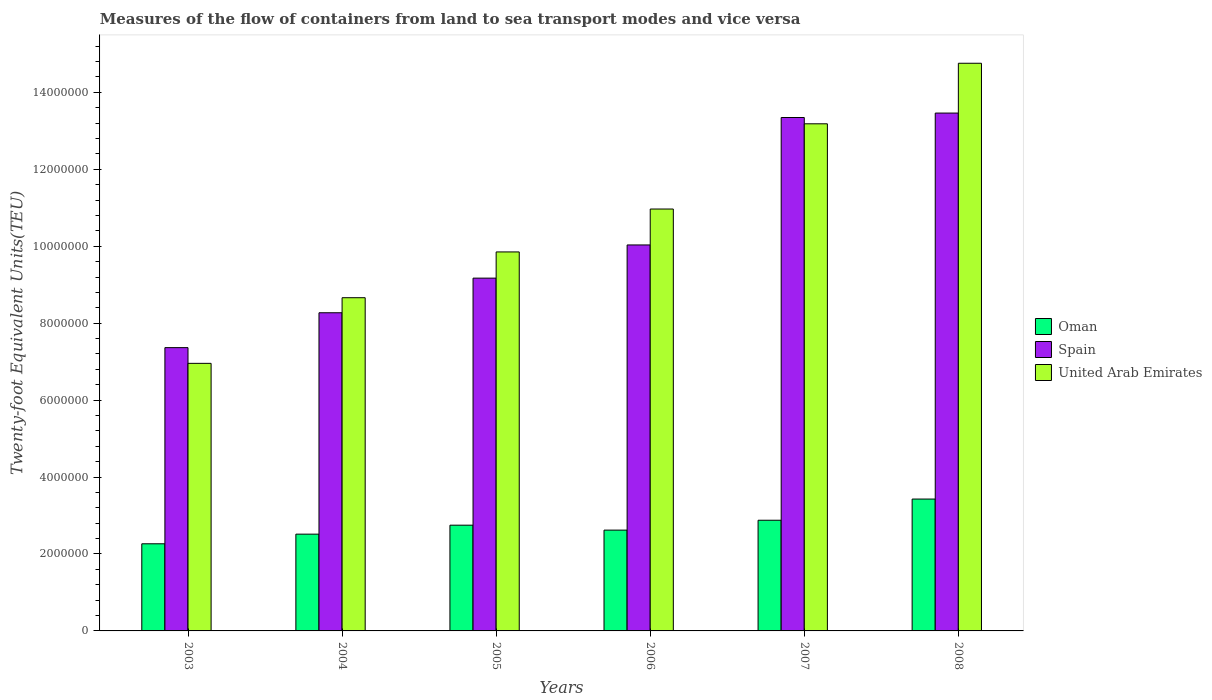How many groups of bars are there?
Your answer should be compact. 6. Are the number of bars per tick equal to the number of legend labels?
Your answer should be very brief. Yes. How many bars are there on the 3rd tick from the left?
Keep it short and to the point. 3. How many bars are there on the 5th tick from the right?
Offer a very short reply. 3. In how many cases, is the number of bars for a given year not equal to the number of legend labels?
Your answer should be compact. 0. What is the container port traffic in Oman in 2003?
Give a very brief answer. 2.26e+06. Across all years, what is the maximum container port traffic in United Arab Emirates?
Ensure brevity in your answer.  1.48e+07. Across all years, what is the minimum container port traffic in Spain?
Provide a short and direct response. 7.36e+06. What is the total container port traffic in Spain in the graph?
Ensure brevity in your answer.  6.16e+07. What is the difference between the container port traffic in Oman in 2004 and that in 2006?
Offer a very short reply. -1.05e+05. What is the difference between the container port traffic in Oman in 2006 and the container port traffic in United Arab Emirates in 2004?
Your response must be concise. -6.04e+06. What is the average container port traffic in Oman per year?
Provide a succinct answer. 2.74e+06. In the year 2007, what is the difference between the container port traffic in Oman and container port traffic in Spain?
Provide a short and direct response. -1.05e+07. In how many years, is the container port traffic in Oman greater than 13600000 TEU?
Provide a succinct answer. 0. What is the ratio of the container port traffic in United Arab Emirates in 2003 to that in 2006?
Ensure brevity in your answer.  0.63. Is the difference between the container port traffic in Oman in 2004 and 2007 greater than the difference between the container port traffic in Spain in 2004 and 2007?
Give a very brief answer. Yes. What is the difference between the highest and the second highest container port traffic in Spain?
Give a very brief answer. 1.15e+05. What is the difference between the highest and the lowest container port traffic in Oman?
Your answer should be compact. 1.16e+06. Is the sum of the container port traffic in Oman in 2005 and 2006 greater than the maximum container port traffic in United Arab Emirates across all years?
Provide a short and direct response. No. What does the 1st bar from the left in 2008 represents?
Offer a terse response. Oman. What does the 3rd bar from the right in 2003 represents?
Your answer should be very brief. Oman. How many bars are there?
Offer a terse response. 18. Are all the bars in the graph horizontal?
Keep it short and to the point. No. How many years are there in the graph?
Your answer should be very brief. 6. What is the difference between two consecutive major ticks on the Y-axis?
Make the answer very short. 2.00e+06. Does the graph contain any zero values?
Make the answer very short. No. Does the graph contain grids?
Give a very brief answer. No. Where does the legend appear in the graph?
Ensure brevity in your answer.  Center right. How are the legend labels stacked?
Keep it short and to the point. Vertical. What is the title of the graph?
Ensure brevity in your answer.  Measures of the flow of containers from land to sea transport modes and vice versa. Does "Myanmar" appear as one of the legend labels in the graph?
Your response must be concise. No. What is the label or title of the X-axis?
Make the answer very short. Years. What is the label or title of the Y-axis?
Keep it short and to the point. Twenty-foot Equivalent Units(TEU). What is the Twenty-foot Equivalent Units(TEU) of Oman in 2003?
Ensure brevity in your answer.  2.26e+06. What is the Twenty-foot Equivalent Units(TEU) in Spain in 2003?
Make the answer very short. 7.36e+06. What is the Twenty-foot Equivalent Units(TEU) of United Arab Emirates in 2003?
Your answer should be compact. 6.96e+06. What is the Twenty-foot Equivalent Units(TEU) of Oman in 2004?
Give a very brief answer. 2.52e+06. What is the Twenty-foot Equivalent Units(TEU) of Spain in 2004?
Ensure brevity in your answer.  8.27e+06. What is the Twenty-foot Equivalent Units(TEU) of United Arab Emirates in 2004?
Offer a terse response. 8.66e+06. What is the Twenty-foot Equivalent Units(TEU) in Oman in 2005?
Offer a very short reply. 2.75e+06. What is the Twenty-foot Equivalent Units(TEU) in Spain in 2005?
Keep it short and to the point. 9.17e+06. What is the Twenty-foot Equivalent Units(TEU) in United Arab Emirates in 2005?
Keep it short and to the point. 9.85e+06. What is the Twenty-foot Equivalent Units(TEU) in Oman in 2006?
Give a very brief answer. 2.62e+06. What is the Twenty-foot Equivalent Units(TEU) of Spain in 2006?
Offer a very short reply. 1.00e+07. What is the Twenty-foot Equivalent Units(TEU) of United Arab Emirates in 2006?
Your answer should be compact. 1.10e+07. What is the Twenty-foot Equivalent Units(TEU) of Oman in 2007?
Provide a succinct answer. 2.88e+06. What is the Twenty-foot Equivalent Units(TEU) in Spain in 2007?
Offer a very short reply. 1.33e+07. What is the Twenty-foot Equivalent Units(TEU) of United Arab Emirates in 2007?
Offer a terse response. 1.32e+07. What is the Twenty-foot Equivalent Units(TEU) of Oman in 2008?
Offer a terse response. 3.43e+06. What is the Twenty-foot Equivalent Units(TEU) in Spain in 2008?
Give a very brief answer. 1.35e+07. What is the Twenty-foot Equivalent Units(TEU) in United Arab Emirates in 2008?
Ensure brevity in your answer.  1.48e+07. Across all years, what is the maximum Twenty-foot Equivalent Units(TEU) in Oman?
Provide a succinct answer. 3.43e+06. Across all years, what is the maximum Twenty-foot Equivalent Units(TEU) in Spain?
Keep it short and to the point. 1.35e+07. Across all years, what is the maximum Twenty-foot Equivalent Units(TEU) of United Arab Emirates?
Give a very brief answer. 1.48e+07. Across all years, what is the minimum Twenty-foot Equivalent Units(TEU) of Oman?
Provide a succinct answer. 2.26e+06. Across all years, what is the minimum Twenty-foot Equivalent Units(TEU) of Spain?
Offer a very short reply. 7.36e+06. Across all years, what is the minimum Twenty-foot Equivalent Units(TEU) in United Arab Emirates?
Offer a terse response. 6.96e+06. What is the total Twenty-foot Equivalent Units(TEU) in Oman in the graph?
Provide a short and direct response. 1.65e+07. What is the total Twenty-foot Equivalent Units(TEU) of Spain in the graph?
Make the answer very short. 6.16e+07. What is the total Twenty-foot Equivalent Units(TEU) in United Arab Emirates in the graph?
Your answer should be very brief. 6.44e+07. What is the difference between the Twenty-foot Equivalent Units(TEU) in Oman in 2003 and that in 2004?
Your answer should be compact. -2.51e+05. What is the difference between the Twenty-foot Equivalent Units(TEU) in Spain in 2003 and that in 2004?
Ensure brevity in your answer.  -9.06e+05. What is the difference between the Twenty-foot Equivalent Units(TEU) in United Arab Emirates in 2003 and that in 2004?
Make the answer very short. -1.71e+06. What is the difference between the Twenty-foot Equivalent Units(TEU) of Oman in 2003 and that in 2005?
Offer a very short reply. -4.84e+05. What is the difference between the Twenty-foot Equivalent Units(TEU) in Spain in 2003 and that in 2005?
Provide a succinct answer. -1.81e+06. What is the difference between the Twenty-foot Equivalent Units(TEU) of United Arab Emirates in 2003 and that in 2005?
Provide a short and direct response. -2.90e+06. What is the difference between the Twenty-foot Equivalent Units(TEU) in Oman in 2003 and that in 2006?
Your answer should be very brief. -3.56e+05. What is the difference between the Twenty-foot Equivalent Units(TEU) in Spain in 2003 and that in 2006?
Offer a terse response. -2.67e+06. What is the difference between the Twenty-foot Equivalent Units(TEU) in United Arab Emirates in 2003 and that in 2006?
Offer a very short reply. -4.01e+06. What is the difference between the Twenty-foot Equivalent Units(TEU) of Oman in 2003 and that in 2007?
Give a very brief answer. -6.12e+05. What is the difference between the Twenty-foot Equivalent Units(TEU) in Spain in 2003 and that in 2007?
Your answer should be compact. -5.98e+06. What is the difference between the Twenty-foot Equivalent Units(TEU) in United Arab Emirates in 2003 and that in 2007?
Ensure brevity in your answer.  -6.23e+06. What is the difference between the Twenty-foot Equivalent Units(TEU) in Oman in 2003 and that in 2008?
Make the answer very short. -1.16e+06. What is the difference between the Twenty-foot Equivalent Units(TEU) in Spain in 2003 and that in 2008?
Ensure brevity in your answer.  -6.10e+06. What is the difference between the Twenty-foot Equivalent Units(TEU) of United Arab Emirates in 2003 and that in 2008?
Keep it short and to the point. -7.80e+06. What is the difference between the Twenty-foot Equivalent Units(TEU) in Oman in 2004 and that in 2005?
Make the answer very short. -2.33e+05. What is the difference between the Twenty-foot Equivalent Units(TEU) of Spain in 2004 and that in 2005?
Your answer should be compact. -9.00e+05. What is the difference between the Twenty-foot Equivalent Units(TEU) of United Arab Emirates in 2004 and that in 2005?
Give a very brief answer. -1.19e+06. What is the difference between the Twenty-foot Equivalent Units(TEU) in Oman in 2004 and that in 2006?
Your answer should be very brief. -1.05e+05. What is the difference between the Twenty-foot Equivalent Units(TEU) in Spain in 2004 and that in 2006?
Ensure brevity in your answer.  -1.76e+06. What is the difference between the Twenty-foot Equivalent Units(TEU) in United Arab Emirates in 2004 and that in 2006?
Provide a succinct answer. -2.31e+06. What is the difference between the Twenty-foot Equivalent Units(TEU) of Oman in 2004 and that in 2007?
Your response must be concise. -3.61e+05. What is the difference between the Twenty-foot Equivalent Units(TEU) of Spain in 2004 and that in 2007?
Provide a succinct answer. -5.08e+06. What is the difference between the Twenty-foot Equivalent Units(TEU) in United Arab Emirates in 2004 and that in 2007?
Make the answer very short. -4.52e+06. What is the difference between the Twenty-foot Equivalent Units(TEU) of Oman in 2004 and that in 2008?
Make the answer very short. -9.12e+05. What is the difference between the Twenty-foot Equivalent Units(TEU) of Spain in 2004 and that in 2008?
Offer a very short reply. -5.19e+06. What is the difference between the Twenty-foot Equivalent Units(TEU) in United Arab Emirates in 2004 and that in 2008?
Offer a terse response. -6.09e+06. What is the difference between the Twenty-foot Equivalent Units(TEU) in Oman in 2005 and that in 2006?
Offer a very short reply. 1.28e+05. What is the difference between the Twenty-foot Equivalent Units(TEU) of Spain in 2005 and that in 2006?
Provide a short and direct response. -8.63e+05. What is the difference between the Twenty-foot Equivalent Units(TEU) in United Arab Emirates in 2005 and that in 2006?
Ensure brevity in your answer.  -1.12e+06. What is the difference between the Twenty-foot Equivalent Units(TEU) of Oman in 2005 and that in 2007?
Provide a succinct answer. -1.28e+05. What is the difference between the Twenty-foot Equivalent Units(TEU) of Spain in 2005 and that in 2007?
Your answer should be very brief. -4.18e+06. What is the difference between the Twenty-foot Equivalent Units(TEU) of United Arab Emirates in 2005 and that in 2007?
Your response must be concise. -3.33e+06. What is the difference between the Twenty-foot Equivalent Units(TEU) in Oman in 2005 and that in 2008?
Give a very brief answer. -6.79e+05. What is the difference between the Twenty-foot Equivalent Units(TEU) in Spain in 2005 and that in 2008?
Your response must be concise. -4.29e+06. What is the difference between the Twenty-foot Equivalent Units(TEU) of United Arab Emirates in 2005 and that in 2008?
Make the answer very short. -4.90e+06. What is the difference between the Twenty-foot Equivalent Units(TEU) of Oman in 2006 and that in 2007?
Your answer should be very brief. -2.57e+05. What is the difference between the Twenty-foot Equivalent Units(TEU) of Spain in 2006 and that in 2007?
Provide a short and direct response. -3.31e+06. What is the difference between the Twenty-foot Equivalent Units(TEU) in United Arab Emirates in 2006 and that in 2007?
Your answer should be very brief. -2.22e+06. What is the difference between the Twenty-foot Equivalent Units(TEU) in Oman in 2006 and that in 2008?
Offer a terse response. -8.08e+05. What is the difference between the Twenty-foot Equivalent Units(TEU) of Spain in 2006 and that in 2008?
Provide a succinct answer. -3.43e+06. What is the difference between the Twenty-foot Equivalent Units(TEU) in United Arab Emirates in 2006 and that in 2008?
Ensure brevity in your answer.  -3.79e+06. What is the difference between the Twenty-foot Equivalent Units(TEU) of Oman in 2007 and that in 2008?
Give a very brief answer. -5.51e+05. What is the difference between the Twenty-foot Equivalent Units(TEU) of Spain in 2007 and that in 2008?
Ensure brevity in your answer.  -1.15e+05. What is the difference between the Twenty-foot Equivalent Units(TEU) in United Arab Emirates in 2007 and that in 2008?
Your answer should be compact. -1.57e+06. What is the difference between the Twenty-foot Equivalent Units(TEU) in Oman in 2003 and the Twenty-foot Equivalent Units(TEU) in Spain in 2004?
Keep it short and to the point. -6.01e+06. What is the difference between the Twenty-foot Equivalent Units(TEU) in Oman in 2003 and the Twenty-foot Equivalent Units(TEU) in United Arab Emirates in 2004?
Ensure brevity in your answer.  -6.40e+06. What is the difference between the Twenty-foot Equivalent Units(TEU) of Spain in 2003 and the Twenty-foot Equivalent Units(TEU) of United Arab Emirates in 2004?
Keep it short and to the point. -1.30e+06. What is the difference between the Twenty-foot Equivalent Units(TEU) in Oman in 2003 and the Twenty-foot Equivalent Units(TEU) in Spain in 2005?
Offer a very short reply. -6.91e+06. What is the difference between the Twenty-foot Equivalent Units(TEU) in Oman in 2003 and the Twenty-foot Equivalent Units(TEU) in United Arab Emirates in 2005?
Provide a short and direct response. -7.59e+06. What is the difference between the Twenty-foot Equivalent Units(TEU) in Spain in 2003 and the Twenty-foot Equivalent Units(TEU) in United Arab Emirates in 2005?
Your response must be concise. -2.49e+06. What is the difference between the Twenty-foot Equivalent Units(TEU) in Oman in 2003 and the Twenty-foot Equivalent Units(TEU) in Spain in 2006?
Your answer should be very brief. -7.77e+06. What is the difference between the Twenty-foot Equivalent Units(TEU) in Oman in 2003 and the Twenty-foot Equivalent Units(TEU) in United Arab Emirates in 2006?
Ensure brevity in your answer.  -8.70e+06. What is the difference between the Twenty-foot Equivalent Units(TEU) of Spain in 2003 and the Twenty-foot Equivalent Units(TEU) of United Arab Emirates in 2006?
Provide a short and direct response. -3.60e+06. What is the difference between the Twenty-foot Equivalent Units(TEU) in Oman in 2003 and the Twenty-foot Equivalent Units(TEU) in Spain in 2007?
Offer a very short reply. -1.11e+07. What is the difference between the Twenty-foot Equivalent Units(TEU) in Oman in 2003 and the Twenty-foot Equivalent Units(TEU) in United Arab Emirates in 2007?
Your answer should be very brief. -1.09e+07. What is the difference between the Twenty-foot Equivalent Units(TEU) of Spain in 2003 and the Twenty-foot Equivalent Units(TEU) of United Arab Emirates in 2007?
Your answer should be compact. -5.82e+06. What is the difference between the Twenty-foot Equivalent Units(TEU) of Oman in 2003 and the Twenty-foot Equivalent Units(TEU) of Spain in 2008?
Ensure brevity in your answer.  -1.12e+07. What is the difference between the Twenty-foot Equivalent Units(TEU) of Oman in 2003 and the Twenty-foot Equivalent Units(TEU) of United Arab Emirates in 2008?
Your answer should be very brief. -1.25e+07. What is the difference between the Twenty-foot Equivalent Units(TEU) of Spain in 2003 and the Twenty-foot Equivalent Units(TEU) of United Arab Emirates in 2008?
Your answer should be compact. -7.39e+06. What is the difference between the Twenty-foot Equivalent Units(TEU) in Oman in 2004 and the Twenty-foot Equivalent Units(TEU) in Spain in 2005?
Make the answer very short. -6.66e+06. What is the difference between the Twenty-foot Equivalent Units(TEU) of Oman in 2004 and the Twenty-foot Equivalent Units(TEU) of United Arab Emirates in 2005?
Provide a short and direct response. -7.34e+06. What is the difference between the Twenty-foot Equivalent Units(TEU) in Spain in 2004 and the Twenty-foot Equivalent Units(TEU) in United Arab Emirates in 2005?
Provide a succinct answer. -1.58e+06. What is the difference between the Twenty-foot Equivalent Units(TEU) in Oman in 2004 and the Twenty-foot Equivalent Units(TEU) in Spain in 2006?
Keep it short and to the point. -7.52e+06. What is the difference between the Twenty-foot Equivalent Units(TEU) of Oman in 2004 and the Twenty-foot Equivalent Units(TEU) of United Arab Emirates in 2006?
Offer a very short reply. -8.45e+06. What is the difference between the Twenty-foot Equivalent Units(TEU) of Spain in 2004 and the Twenty-foot Equivalent Units(TEU) of United Arab Emirates in 2006?
Your response must be concise. -2.70e+06. What is the difference between the Twenty-foot Equivalent Units(TEU) of Oman in 2004 and the Twenty-foot Equivalent Units(TEU) of Spain in 2007?
Your response must be concise. -1.08e+07. What is the difference between the Twenty-foot Equivalent Units(TEU) in Oman in 2004 and the Twenty-foot Equivalent Units(TEU) in United Arab Emirates in 2007?
Ensure brevity in your answer.  -1.07e+07. What is the difference between the Twenty-foot Equivalent Units(TEU) in Spain in 2004 and the Twenty-foot Equivalent Units(TEU) in United Arab Emirates in 2007?
Offer a very short reply. -4.91e+06. What is the difference between the Twenty-foot Equivalent Units(TEU) of Oman in 2004 and the Twenty-foot Equivalent Units(TEU) of Spain in 2008?
Provide a succinct answer. -1.09e+07. What is the difference between the Twenty-foot Equivalent Units(TEU) of Oman in 2004 and the Twenty-foot Equivalent Units(TEU) of United Arab Emirates in 2008?
Give a very brief answer. -1.22e+07. What is the difference between the Twenty-foot Equivalent Units(TEU) of Spain in 2004 and the Twenty-foot Equivalent Units(TEU) of United Arab Emirates in 2008?
Offer a very short reply. -6.49e+06. What is the difference between the Twenty-foot Equivalent Units(TEU) of Oman in 2005 and the Twenty-foot Equivalent Units(TEU) of Spain in 2006?
Your response must be concise. -7.28e+06. What is the difference between the Twenty-foot Equivalent Units(TEU) in Oman in 2005 and the Twenty-foot Equivalent Units(TEU) in United Arab Emirates in 2006?
Keep it short and to the point. -8.22e+06. What is the difference between the Twenty-foot Equivalent Units(TEU) in Spain in 2005 and the Twenty-foot Equivalent Units(TEU) in United Arab Emirates in 2006?
Provide a short and direct response. -1.80e+06. What is the difference between the Twenty-foot Equivalent Units(TEU) of Oman in 2005 and the Twenty-foot Equivalent Units(TEU) of Spain in 2007?
Offer a very short reply. -1.06e+07. What is the difference between the Twenty-foot Equivalent Units(TEU) of Oman in 2005 and the Twenty-foot Equivalent Units(TEU) of United Arab Emirates in 2007?
Keep it short and to the point. -1.04e+07. What is the difference between the Twenty-foot Equivalent Units(TEU) in Spain in 2005 and the Twenty-foot Equivalent Units(TEU) in United Arab Emirates in 2007?
Your answer should be compact. -4.01e+06. What is the difference between the Twenty-foot Equivalent Units(TEU) of Oman in 2005 and the Twenty-foot Equivalent Units(TEU) of Spain in 2008?
Offer a very short reply. -1.07e+07. What is the difference between the Twenty-foot Equivalent Units(TEU) of Oman in 2005 and the Twenty-foot Equivalent Units(TEU) of United Arab Emirates in 2008?
Give a very brief answer. -1.20e+07. What is the difference between the Twenty-foot Equivalent Units(TEU) in Spain in 2005 and the Twenty-foot Equivalent Units(TEU) in United Arab Emirates in 2008?
Keep it short and to the point. -5.59e+06. What is the difference between the Twenty-foot Equivalent Units(TEU) of Oman in 2006 and the Twenty-foot Equivalent Units(TEU) of Spain in 2007?
Offer a very short reply. -1.07e+07. What is the difference between the Twenty-foot Equivalent Units(TEU) in Oman in 2006 and the Twenty-foot Equivalent Units(TEU) in United Arab Emirates in 2007?
Offer a terse response. -1.06e+07. What is the difference between the Twenty-foot Equivalent Units(TEU) in Spain in 2006 and the Twenty-foot Equivalent Units(TEU) in United Arab Emirates in 2007?
Your answer should be very brief. -3.15e+06. What is the difference between the Twenty-foot Equivalent Units(TEU) of Oman in 2006 and the Twenty-foot Equivalent Units(TEU) of Spain in 2008?
Provide a short and direct response. -1.08e+07. What is the difference between the Twenty-foot Equivalent Units(TEU) of Oman in 2006 and the Twenty-foot Equivalent Units(TEU) of United Arab Emirates in 2008?
Ensure brevity in your answer.  -1.21e+07. What is the difference between the Twenty-foot Equivalent Units(TEU) in Spain in 2006 and the Twenty-foot Equivalent Units(TEU) in United Arab Emirates in 2008?
Your answer should be very brief. -4.72e+06. What is the difference between the Twenty-foot Equivalent Units(TEU) in Oman in 2007 and the Twenty-foot Equivalent Units(TEU) in Spain in 2008?
Make the answer very short. -1.06e+07. What is the difference between the Twenty-foot Equivalent Units(TEU) in Oman in 2007 and the Twenty-foot Equivalent Units(TEU) in United Arab Emirates in 2008?
Give a very brief answer. -1.19e+07. What is the difference between the Twenty-foot Equivalent Units(TEU) in Spain in 2007 and the Twenty-foot Equivalent Units(TEU) in United Arab Emirates in 2008?
Ensure brevity in your answer.  -1.41e+06. What is the average Twenty-foot Equivalent Units(TEU) of Oman per year?
Make the answer very short. 2.74e+06. What is the average Twenty-foot Equivalent Units(TEU) of Spain per year?
Give a very brief answer. 1.03e+07. What is the average Twenty-foot Equivalent Units(TEU) of United Arab Emirates per year?
Provide a succinct answer. 1.07e+07. In the year 2003, what is the difference between the Twenty-foot Equivalent Units(TEU) of Oman and Twenty-foot Equivalent Units(TEU) of Spain?
Offer a terse response. -5.10e+06. In the year 2003, what is the difference between the Twenty-foot Equivalent Units(TEU) of Oman and Twenty-foot Equivalent Units(TEU) of United Arab Emirates?
Provide a succinct answer. -4.69e+06. In the year 2003, what is the difference between the Twenty-foot Equivalent Units(TEU) of Spain and Twenty-foot Equivalent Units(TEU) of United Arab Emirates?
Your answer should be very brief. 4.09e+05. In the year 2004, what is the difference between the Twenty-foot Equivalent Units(TEU) in Oman and Twenty-foot Equivalent Units(TEU) in Spain?
Provide a short and direct response. -5.75e+06. In the year 2004, what is the difference between the Twenty-foot Equivalent Units(TEU) in Oman and Twenty-foot Equivalent Units(TEU) in United Arab Emirates?
Ensure brevity in your answer.  -6.15e+06. In the year 2004, what is the difference between the Twenty-foot Equivalent Units(TEU) of Spain and Twenty-foot Equivalent Units(TEU) of United Arab Emirates?
Offer a very short reply. -3.91e+05. In the year 2005, what is the difference between the Twenty-foot Equivalent Units(TEU) in Oman and Twenty-foot Equivalent Units(TEU) in Spain?
Your answer should be very brief. -6.42e+06. In the year 2005, what is the difference between the Twenty-foot Equivalent Units(TEU) of Oman and Twenty-foot Equivalent Units(TEU) of United Arab Emirates?
Ensure brevity in your answer.  -7.10e+06. In the year 2005, what is the difference between the Twenty-foot Equivalent Units(TEU) of Spain and Twenty-foot Equivalent Units(TEU) of United Arab Emirates?
Your response must be concise. -6.81e+05. In the year 2006, what is the difference between the Twenty-foot Equivalent Units(TEU) of Oman and Twenty-foot Equivalent Units(TEU) of Spain?
Offer a very short reply. -7.41e+06. In the year 2006, what is the difference between the Twenty-foot Equivalent Units(TEU) of Oman and Twenty-foot Equivalent Units(TEU) of United Arab Emirates?
Offer a terse response. -8.35e+06. In the year 2006, what is the difference between the Twenty-foot Equivalent Units(TEU) in Spain and Twenty-foot Equivalent Units(TEU) in United Arab Emirates?
Give a very brief answer. -9.34e+05. In the year 2007, what is the difference between the Twenty-foot Equivalent Units(TEU) of Oman and Twenty-foot Equivalent Units(TEU) of Spain?
Give a very brief answer. -1.05e+07. In the year 2007, what is the difference between the Twenty-foot Equivalent Units(TEU) in Oman and Twenty-foot Equivalent Units(TEU) in United Arab Emirates?
Keep it short and to the point. -1.03e+07. In the year 2007, what is the difference between the Twenty-foot Equivalent Units(TEU) of Spain and Twenty-foot Equivalent Units(TEU) of United Arab Emirates?
Keep it short and to the point. 1.64e+05. In the year 2008, what is the difference between the Twenty-foot Equivalent Units(TEU) of Oman and Twenty-foot Equivalent Units(TEU) of Spain?
Give a very brief answer. -1.00e+07. In the year 2008, what is the difference between the Twenty-foot Equivalent Units(TEU) of Oman and Twenty-foot Equivalent Units(TEU) of United Arab Emirates?
Provide a succinct answer. -1.13e+07. In the year 2008, what is the difference between the Twenty-foot Equivalent Units(TEU) of Spain and Twenty-foot Equivalent Units(TEU) of United Arab Emirates?
Your answer should be very brief. -1.29e+06. What is the ratio of the Twenty-foot Equivalent Units(TEU) in Oman in 2003 to that in 2004?
Make the answer very short. 0.9. What is the ratio of the Twenty-foot Equivalent Units(TEU) in Spain in 2003 to that in 2004?
Your response must be concise. 0.89. What is the ratio of the Twenty-foot Equivalent Units(TEU) of United Arab Emirates in 2003 to that in 2004?
Ensure brevity in your answer.  0.8. What is the ratio of the Twenty-foot Equivalent Units(TEU) of Oman in 2003 to that in 2005?
Ensure brevity in your answer.  0.82. What is the ratio of the Twenty-foot Equivalent Units(TEU) in Spain in 2003 to that in 2005?
Ensure brevity in your answer.  0.8. What is the ratio of the Twenty-foot Equivalent Units(TEU) in United Arab Emirates in 2003 to that in 2005?
Your answer should be compact. 0.71. What is the ratio of the Twenty-foot Equivalent Units(TEU) in Oman in 2003 to that in 2006?
Keep it short and to the point. 0.86. What is the ratio of the Twenty-foot Equivalent Units(TEU) in Spain in 2003 to that in 2006?
Ensure brevity in your answer.  0.73. What is the ratio of the Twenty-foot Equivalent Units(TEU) of United Arab Emirates in 2003 to that in 2006?
Provide a succinct answer. 0.63. What is the ratio of the Twenty-foot Equivalent Units(TEU) of Oman in 2003 to that in 2007?
Your answer should be compact. 0.79. What is the ratio of the Twenty-foot Equivalent Units(TEU) of Spain in 2003 to that in 2007?
Provide a short and direct response. 0.55. What is the ratio of the Twenty-foot Equivalent Units(TEU) in United Arab Emirates in 2003 to that in 2007?
Your answer should be compact. 0.53. What is the ratio of the Twenty-foot Equivalent Units(TEU) in Oman in 2003 to that in 2008?
Your response must be concise. 0.66. What is the ratio of the Twenty-foot Equivalent Units(TEU) in Spain in 2003 to that in 2008?
Your answer should be very brief. 0.55. What is the ratio of the Twenty-foot Equivalent Units(TEU) in United Arab Emirates in 2003 to that in 2008?
Make the answer very short. 0.47. What is the ratio of the Twenty-foot Equivalent Units(TEU) in Oman in 2004 to that in 2005?
Provide a short and direct response. 0.92. What is the ratio of the Twenty-foot Equivalent Units(TEU) in Spain in 2004 to that in 2005?
Provide a short and direct response. 0.9. What is the ratio of the Twenty-foot Equivalent Units(TEU) of United Arab Emirates in 2004 to that in 2005?
Provide a short and direct response. 0.88. What is the ratio of the Twenty-foot Equivalent Units(TEU) of Oman in 2004 to that in 2006?
Keep it short and to the point. 0.96. What is the ratio of the Twenty-foot Equivalent Units(TEU) of Spain in 2004 to that in 2006?
Ensure brevity in your answer.  0.82. What is the ratio of the Twenty-foot Equivalent Units(TEU) of United Arab Emirates in 2004 to that in 2006?
Provide a succinct answer. 0.79. What is the ratio of the Twenty-foot Equivalent Units(TEU) in Oman in 2004 to that in 2007?
Provide a short and direct response. 0.87. What is the ratio of the Twenty-foot Equivalent Units(TEU) in Spain in 2004 to that in 2007?
Your response must be concise. 0.62. What is the ratio of the Twenty-foot Equivalent Units(TEU) of United Arab Emirates in 2004 to that in 2007?
Ensure brevity in your answer.  0.66. What is the ratio of the Twenty-foot Equivalent Units(TEU) in Oman in 2004 to that in 2008?
Your answer should be compact. 0.73. What is the ratio of the Twenty-foot Equivalent Units(TEU) in Spain in 2004 to that in 2008?
Your response must be concise. 0.61. What is the ratio of the Twenty-foot Equivalent Units(TEU) of United Arab Emirates in 2004 to that in 2008?
Keep it short and to the point. 0.59. What is the ratio of the Twenty-foot Equivalent Units(TEU) in Oman in 2005 to that in 2006?
Keep it short and to the point. 1.05. What is the ratio of the Twenty-foot Equivalent Units(TEU) of Spain in 2005 to that in 2006?
Offer a terse response. 0.91. What is the ratio of the Twenty-foot Equivalent Units(TEU) in United Arab Emirates in 2005 to that in 2006?
Provide a short and direct response. 0.9. What is the ratio of the Twenty-foot Equivalent Units(TEU) in Oman in 2005 to that in 2007?
Give a very brief answer. 0.96. What is the ratio of the Twenty-foot Equivalent Units(TEU) in Spain in 2005 to that in 2007?
Ensure brevity in your answer.  0.69. What is the ratio of the Twenty-foot Equivalent Units(TEU) of United Arab Emirates in 2005 to that in 2007?
Keep it short and to the point. 0.75. What is the ratio of the Twenty-foot Equivalent Units(TEU) of Oman in 2005 to that in 2008?
Your answer should be compact. 0.8. What is the ratio of the Twenty-foot Equivalent Units(TEU) of Spain in 2005 to that in 2008?
Give a very brief answer. 0.68. What is the ratio of the Twenty-foot Equivalent Units(TEU) in United Arab Emirates in 2005 to that in 2008?
Your response must be concise. 0.67. What is the ratio of the Twenty-foot Equivalent Units(TEU) in Oman in 2006 to that in 2007?
Ensure brevity in your answer.  0.91. What is the ratio of the Twenty-foot Equivalent Units(TEU) in Spain in 2006 to that in 2007?
Give a very brief answer. 0.75. What is the ratio of the Twenty-foot Equivalent Units(TEU) of United Arab Emirates in 2006 to that in 2007?
Make the answer very short. 0.83. What is the ratio of the Twenty-foot Equivalent Units(TEU) in Oman in 2006 to that in 2008?
Keep it short and to the point. 0.76. What is the ratio of the Twenty-foot Equivalent Units(TEU) in Spain in 2006 to that in 2008?
Ensure brevity in your answer.  0.75. What is the ratio of the Twenty-foot Equivalent Units(TEU) in United Arab Emirates in 2006 to that in 2008?
Make the answer very short. 0.74. What is the ratio of the Twenty-foot Equivalent Units(TEU) in Oman in 2007 to that in 2008?
Offer a very short reply. 0.84. What is the ratio of the Twenty-foot Equivalent Units(TEU) of Spain in 2007 to that in 2008?
Make the answer very short. 0.99. What is the ratio of the Twenty-foot Equivalent Units(TEU) of United Arab Emirates in 2007 to that in 2008?
Ensure brevity in your answer.  0.89. What is the difference between the highest and the second highest Twenty-foot Equivalent Units(TEU) in Oman?
Make the answer very short. 5.51e+05. What is the difference between the highest and the second highest Twenty-foot Equivalent Units(TEU) in Spain?
Provide a succinct answer. 1.15e+05. What is the difference between the highest and the second highest Twenty-foot Equivalent Units(TEU) of United Arab Emirates?
Keep it short and to the point. 1.57e+06. What is the difference between the highest and the lowest Twenty-foot Equivalent Units(TEU) of Oman?
Provide a succinct answer. 1.16e+06. What is the difference between the highest and the lowest Twenty-foot Equivalent Units(TEU) in Spain?
Ensure brevity in your answer.  6.10e+06. What is the difference between the highest and the lowest Twenty-foot Equivalent Units(TEU) of United Arab Emirates?
Your answer should be compact. 7.80e+06. 